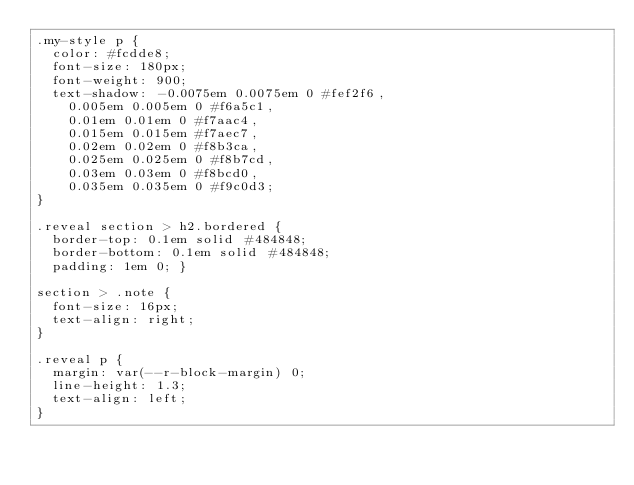<code> <loc_0><loc_0><loc_500><loc_500><_CSS_>.my-style p {
  color: #fcdde8;
  font-size: 180px;
  font-weight: 900;
  text-shadow: -0.0075em 0.0075em 0 #fef2f6,
    0.005em 0.005em 0 #f6a5c1,
    0.01em 0.01em 0 #f7aac4,
    0.015em 0.015em #f7aec7,
    0.02em 0.02em 0 #f8b3ca,
    0.025em 0.025em 0 #f8b7cd,
    0.03em 0.03em 0 #f8bcd0,
    0.035em 0.035em 0 #f9c0d3;
}

.reveal section > h2.bordered {
  border-top: 0.1em solid #484848;
  border-bottom: 0.1em solid #484848;
  padding: 1em 0; }

section > .note {
  font-size: 16px;
  text-align: right;
}

.reveal p {
  margin: var(--r-block-margin) 0;
  line-height: 1.3;
  text-align: left;
}</code> 